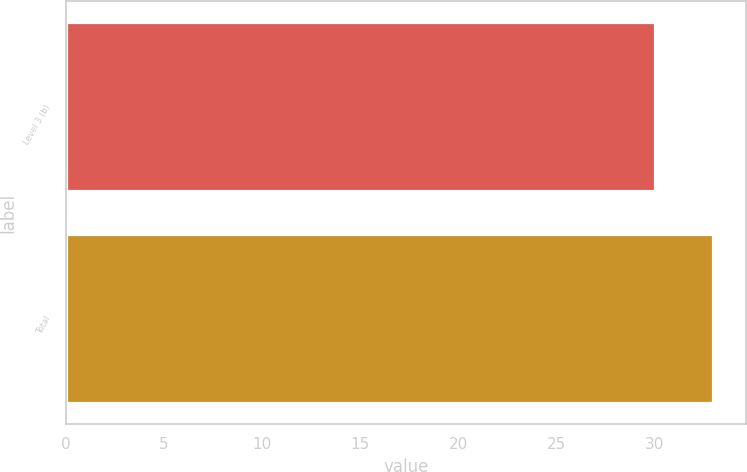<chart> <loc_0><loc_0><loc_500><loc_500><bar_chart><fcel>Level 3 (b)<fcel>Total<nl><fcel>30<fcel>33<nl></chart> 